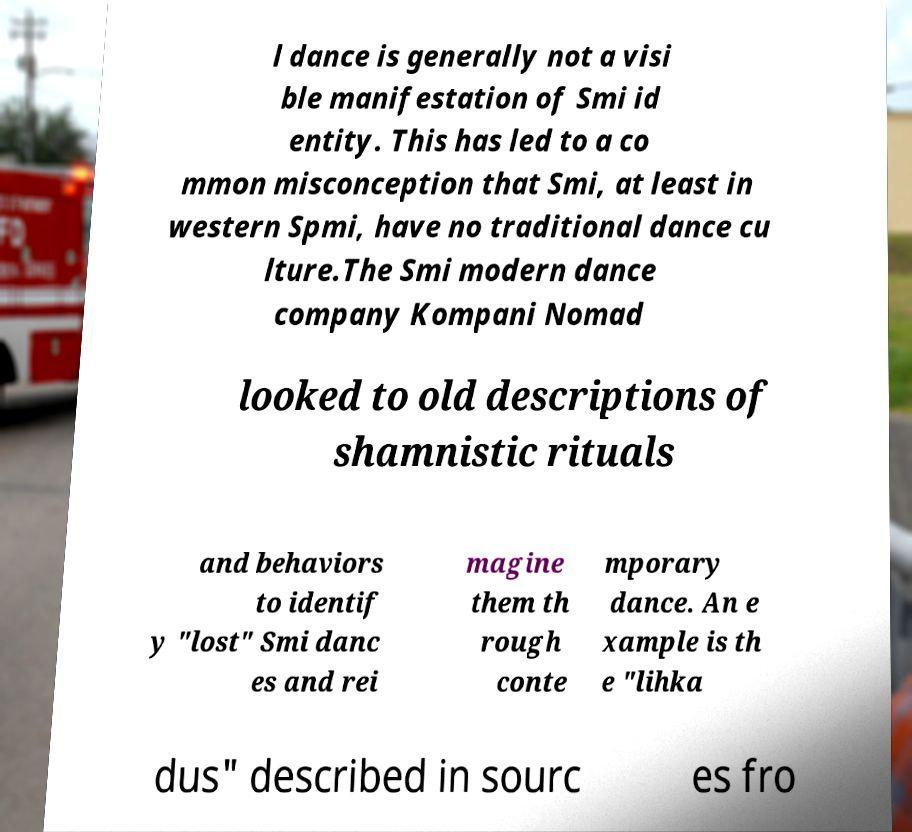Can you accurately transcribe the text from the provided image for me? l dance is generally not a visi ble manifestation of Smi id entity. This has led to a co mmon misconception that Smi, at least in western Spmi, have no traditional dance cu lture.The Smi modern dance company Kompani Nomad looked to old descriptions of shamnistic rituals and behaviors to identif y "lost" Smi danc es and rei magine them th rough conte mporary dance. An e xample is th e "lihka dus" described in sourc es fro 